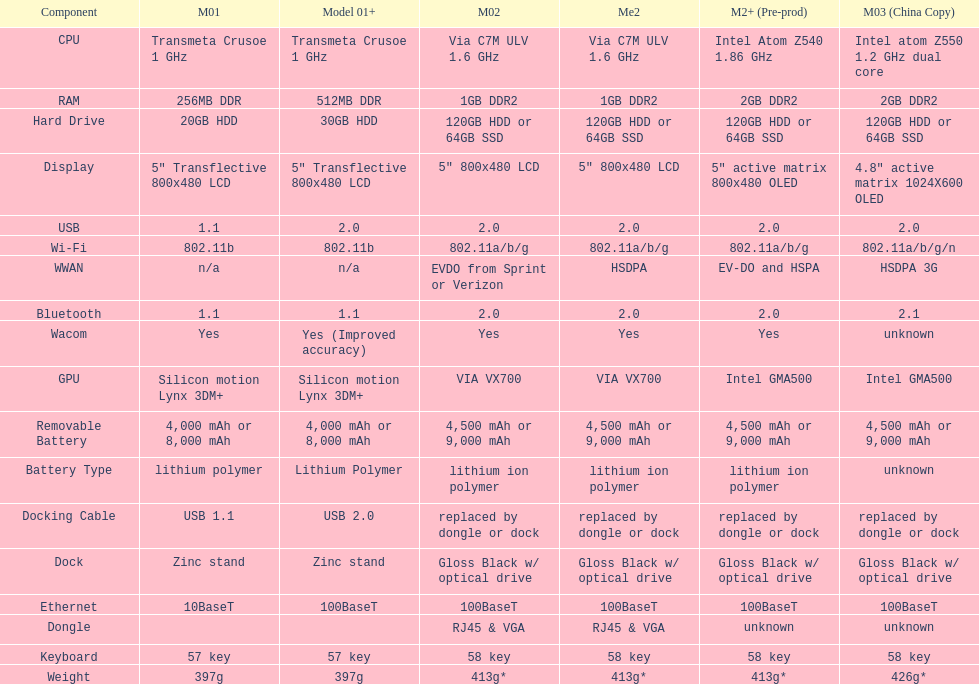Which model weighs the most, according to the table? Model 03 (china copy). 